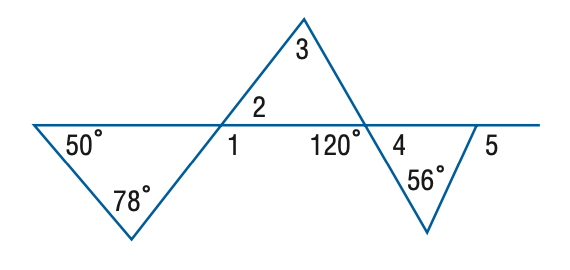Question: Find the measure of \angle 4 in the figure.
Choices:
A. 52
B. 56
C. 58
D. 60
Answer with the letter. Answer: D Question: Find the measure of \angle 2 in the figure.
Choices:
A. 50
B. 52
C. 56
D. 60
Answer with the letter. Answer: B 